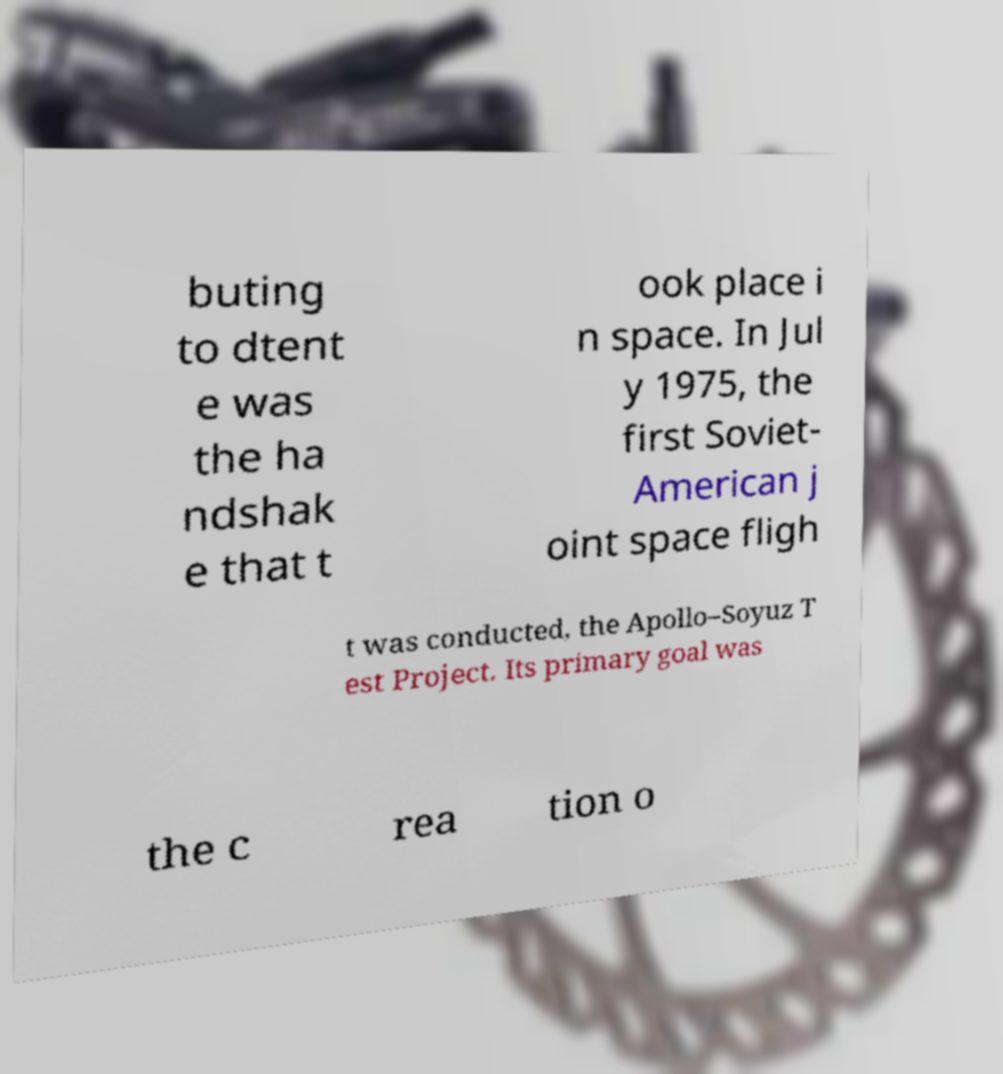What messages or text are displayed in this image? I need them in a readable, typed format. buting to dtent e was the ha ndshak e that t ook place i n space. In Jul y 1975, the first Soviet- American j oint space fligh t was conducted, the Apollo–Soyuz T est Project. Its primary goal was the c rea tion o 